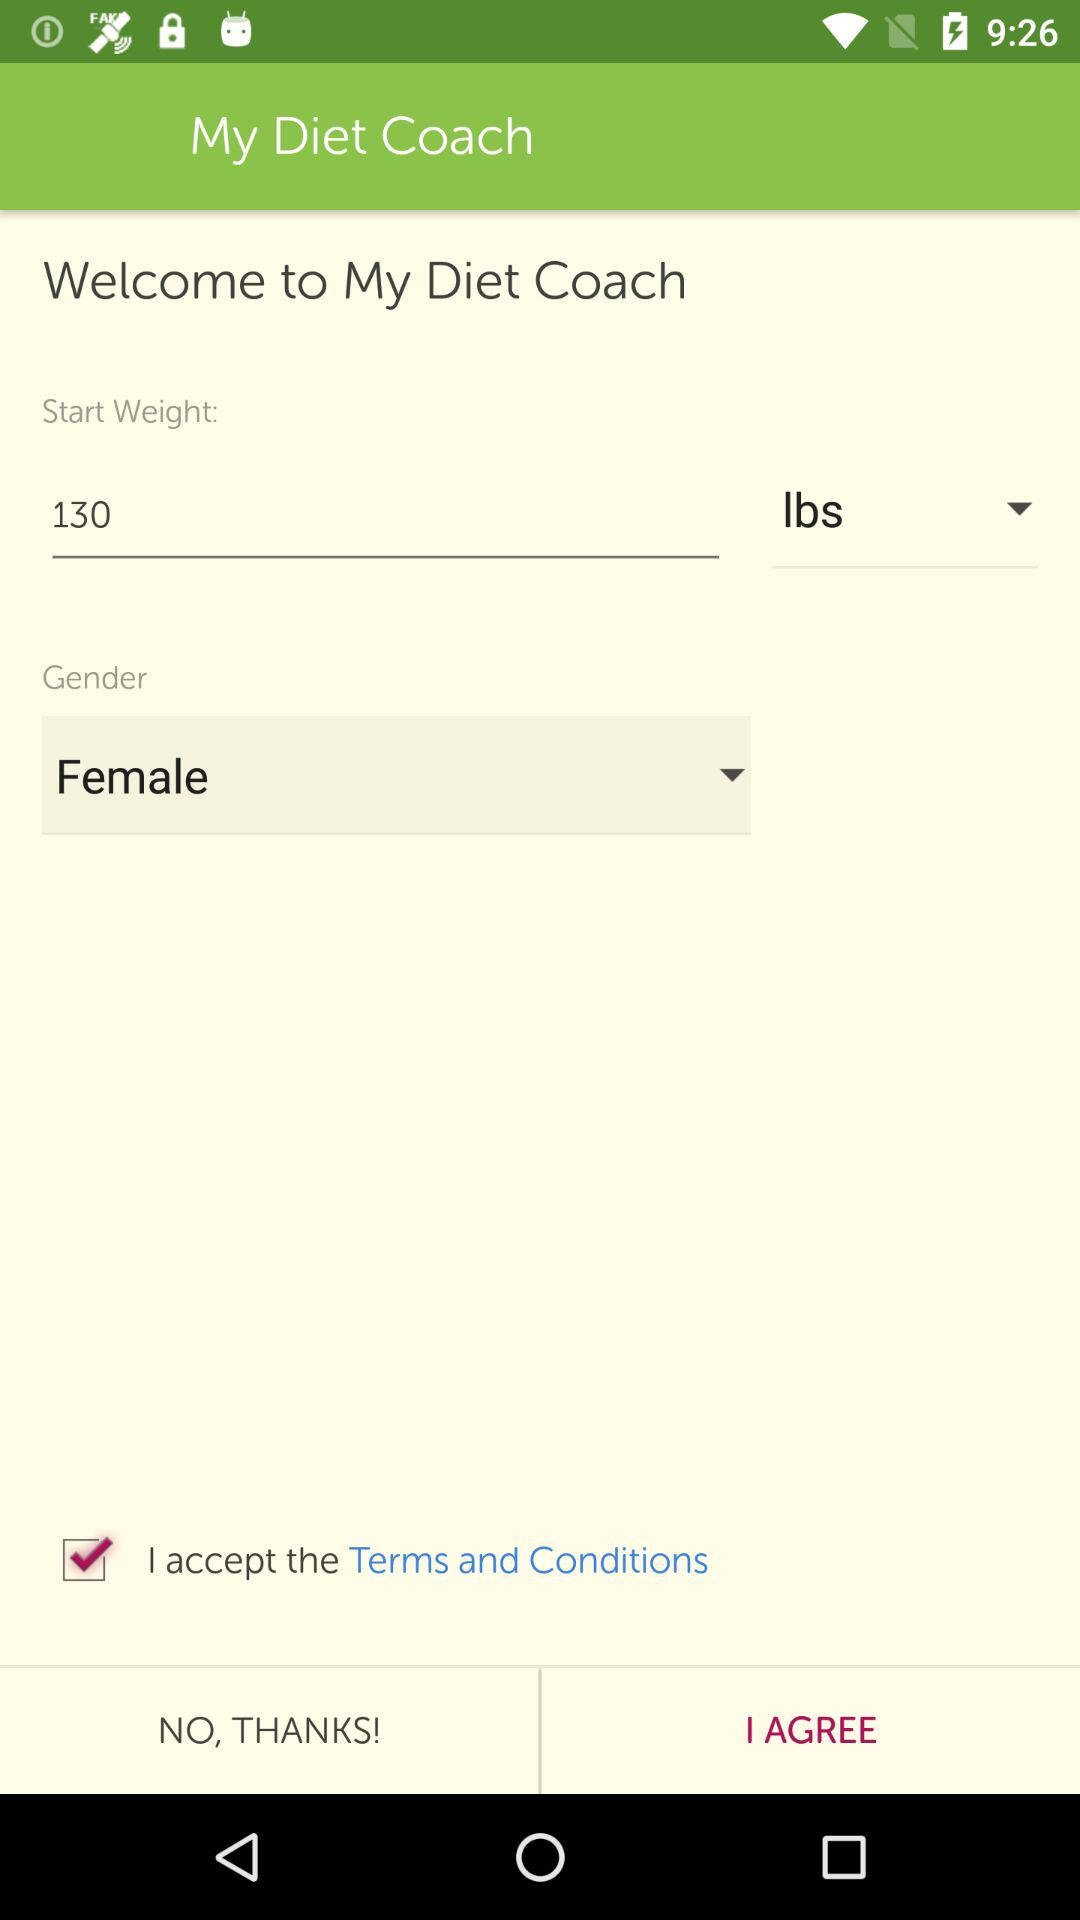What is the mentioned start weight? The mentioned start weight is 130 lbs. 